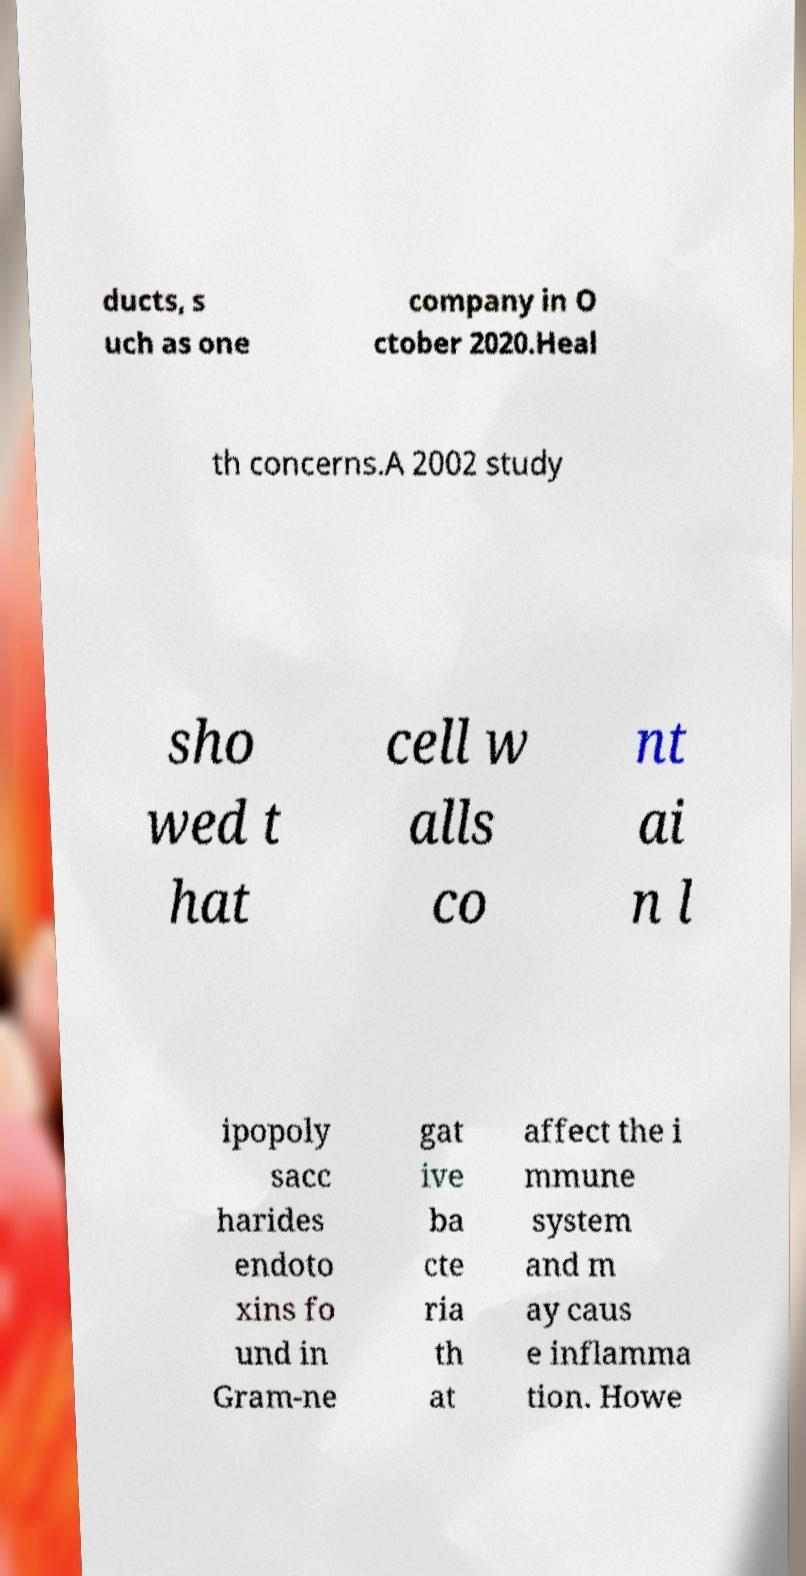For documentation purposes, I need the text within this image transcribed. Could you provide that? ducts, s uch as one company in O ctober 2020.Heal th concerns.A 2002 study sho wed t hat cell w alls co nt ai n l ipopoly sacc harides endoto xins fo und in Gram-ne gat ive ba cte ria th at affect the i mmune system and m ay caus e inflamma tion. Howe 